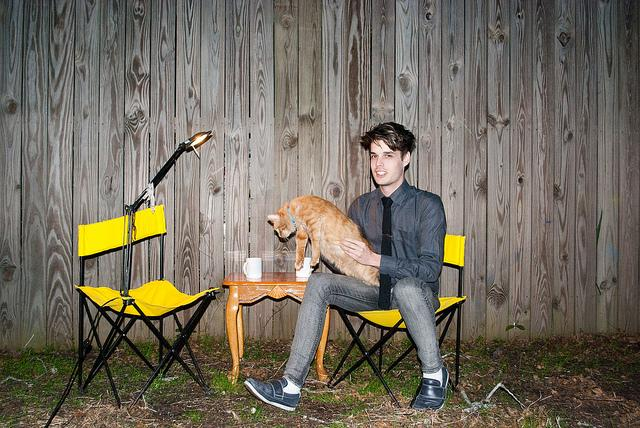What is the breed of this cat?

Choices:
A) ragdoll
B) persian
C) maine coon
D) scottish fold ragdoll 